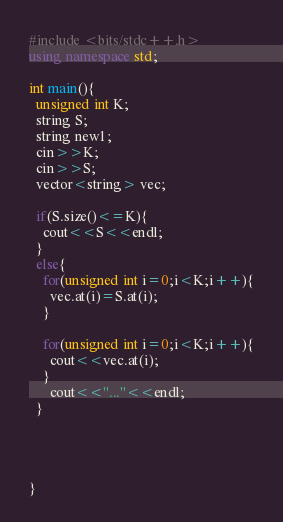Convert code to text. <code><loc_0><loc_0><loc_500><loc_500><_C++_>#include <bits/stdc++.h>
using namespace std;

int main(){
  unsigned int K;
  string S;
  string new1;
  cin>>K;
  cin>>S;
  vector<string> vec;
  
  if(S.size()<=K){
    cout<<S<<endl;
  }
  else{
    for(unsigned int i=0;i<K;i++){
      vec.at(i)=S.at(i);
    }
    
    for(unsigned int i=0;i<K;i++){
      cout<<vec.at(i);
    }
      cout<<"..."<<endl;
  }
  
  
  
  
}
</code> 